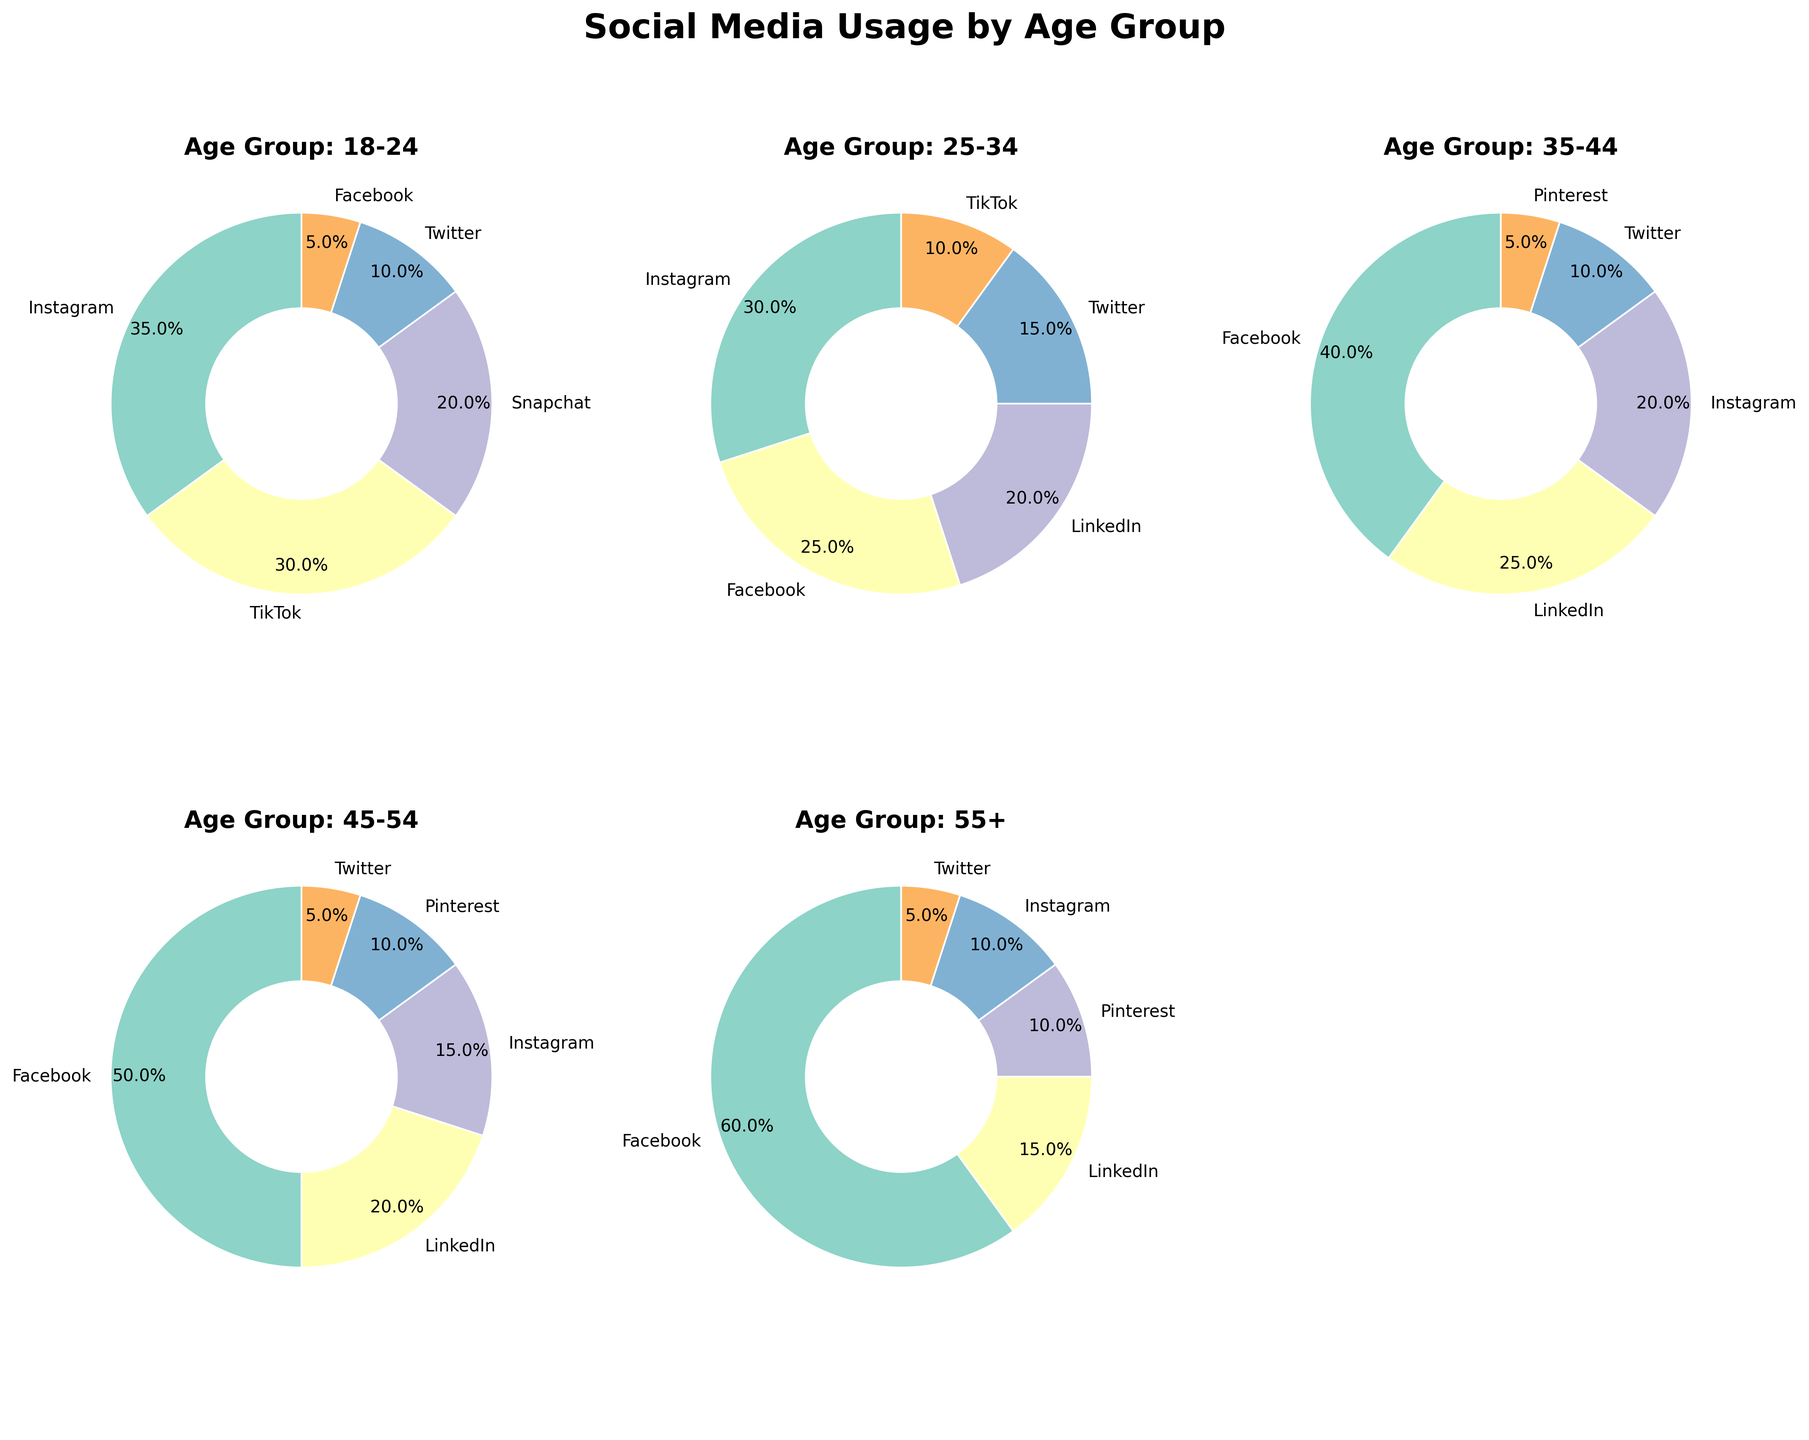Which social media platform is the most popular among the 18-24 age group? By visually inspecting the pie chart for the 18-24 age group, we see the largest section belongs to Instagram with 35%.
Answer: Instagram Which age group shows the highest usage of Facebook? By comparing the size of the Facebook sections in each age group's pie chart, the 55+ age group has the largest portion, indicating 60% usage.
Answer: 55+ What is the total percentage of Instagram usage for the 25-34 and 35-44 age groups combined? The Instagram usage is 30% for the 25-34 age group and 20% for the 35-44 age group. Summing these percentages: 30% + 20% = 50%.
Answer: 50% How does the percentage of LinkedIn usage compare between the 35-44 and 55+ age groups? The pie chart shows that LinkedIn usage is 25% for the 35-44 age group and 15% for the 55+ age group. Therefore, LinkedIn usage is higher for the 35-44 age group.
Answer: 35-44 age group Among the listed age groups, which one shows equal usage percentages for Instagram and Pinterest? By checking each pie chart, the 55+ age group has both Instagram and Pinterest at 10%.
Answer: 55+ What is the combined percentage of Twitter usage for all age groups? Adding the Twitter usage percentages from all age groups: 10% (18-24) + 15% (25-34) + 10% (35-44) + 5% (45-54) + 5% (55+). The total is: 10% + 15% + 10% + 5% + 5% = 45%.
Answer: 45% Which platform has the least usage among the 25-34 age group? By visually inspecting the pie chart for the 25-34 age group, the smallest section belongs to TikTok with 10%.
Answer: TikTok What percentage of the 45-54 age group uses Facebook, and how does this compare to Instagram usage in the same group? The pie chart indicates that 50% of the 45-54 age group uses Facebook and 15% use Instagram. Therefore, the percentage for Facebook is higher by 35%.
Answer: Facebook is higher by 35% What percentage difference is there between Pinterest usage for the 35-44 and 55+ age groups? Pinterest usage for the 35-44 age group is 5%, and for the 55+ age group, it is 10%. The difference is 10% - 5% = 5%.
Answer: 5% How much greater is Snapchat usage than Twitter among the 18-24 age group? For the 18-24 age group, Snapchat usage is 20% and Twitter usage is 10%. The difference is 20% - 10% = 10%.
Answer: 10% 